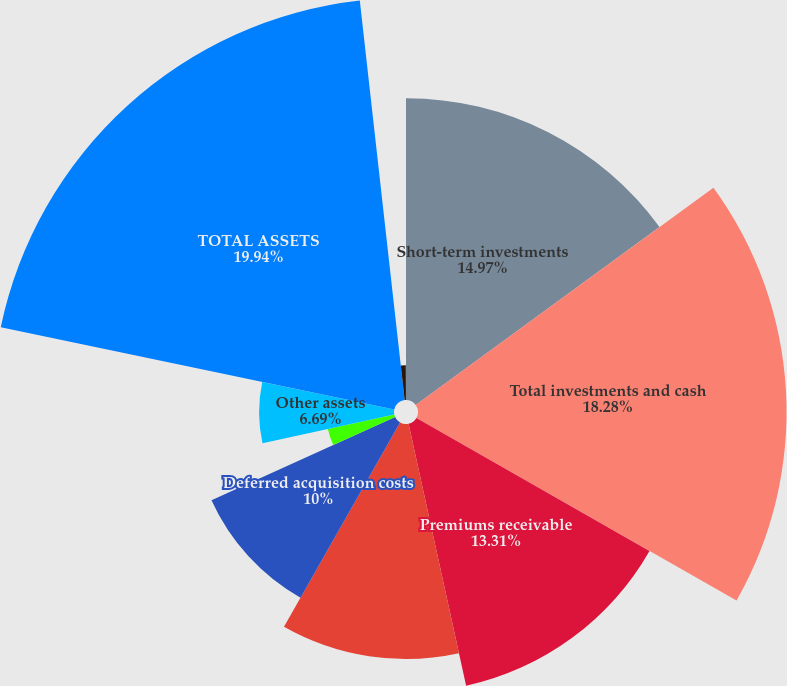<chart> <loc_0><loc_0><loc_500><loc_500><pie_chart><fcel>Short-term investments<fcel>Total investments and cash<fcel>Premiums receivable<fcel>Reinsurance receivables<fcel>Deferred acquisition costs<fcel>Prepaid reinsurance premiums<fcel>Other assets<fcel>TOTAL ASSETS<fcel>Funds held under reinsurance<fcel>Commission reserves<nl><fcel>14.97%<fcel>18.28%<fcel>13.31%<fcel>11.66%<fcel>10.0%<fcel>3.37%<fcel>6.69%<fcel>19.94%<fcel>1.72%<fcel>0.06%<nl></chart> 